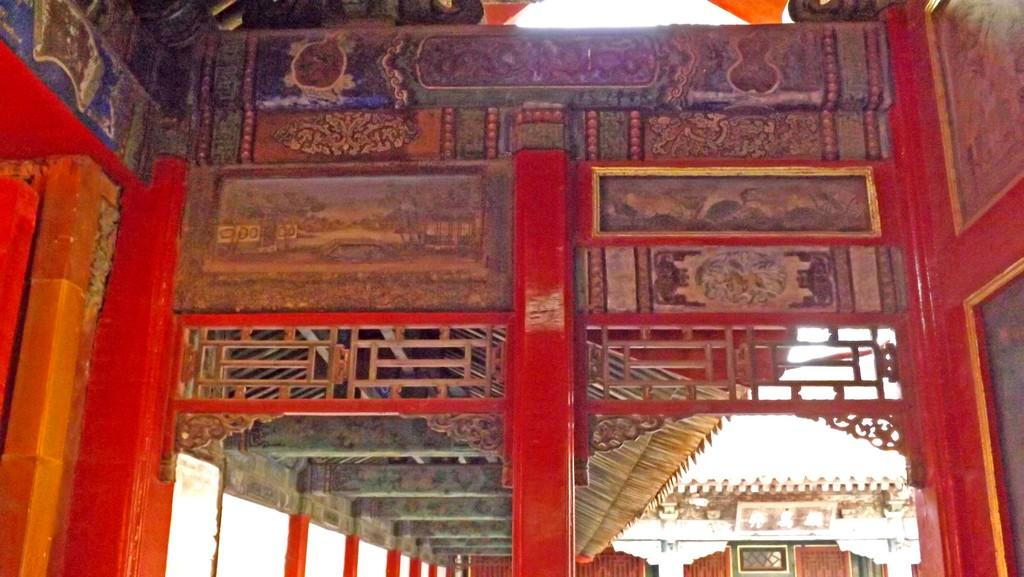What type of location is shown in the image? The interior of a building is depicted in the image. What color are the walls of the building? The walls of the building are in red color. Are there any patterns or designs on the walls? Yes, there are designs on the walls. How many patches of grass can be seen on the walls in the image? There are no patches of grass visible on the walls in the image, as the walls are red and have designs on them. 